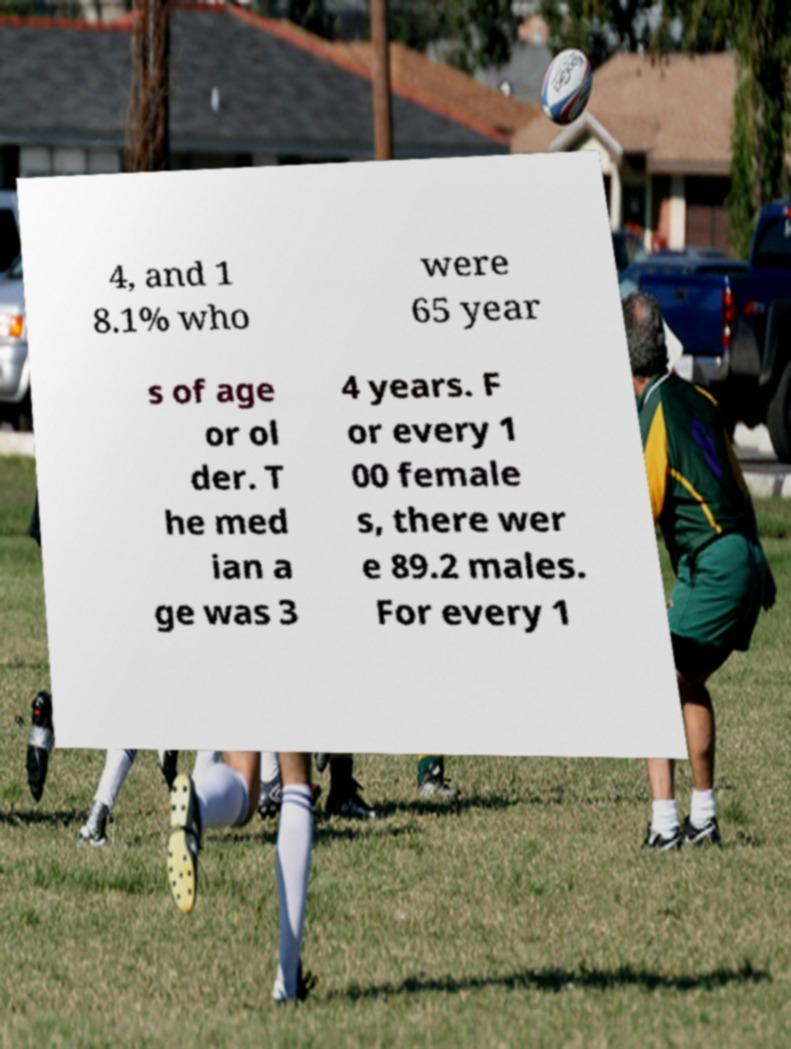For documentation purposes, I need the text within this image transcribed. Could you provide that? 4, and 1 8.1% who were 65 year s of age or ol der. T he med ian a ge was 3 4 years. F or every 1 00 female s, there wer e 89.2 males. For every 1 